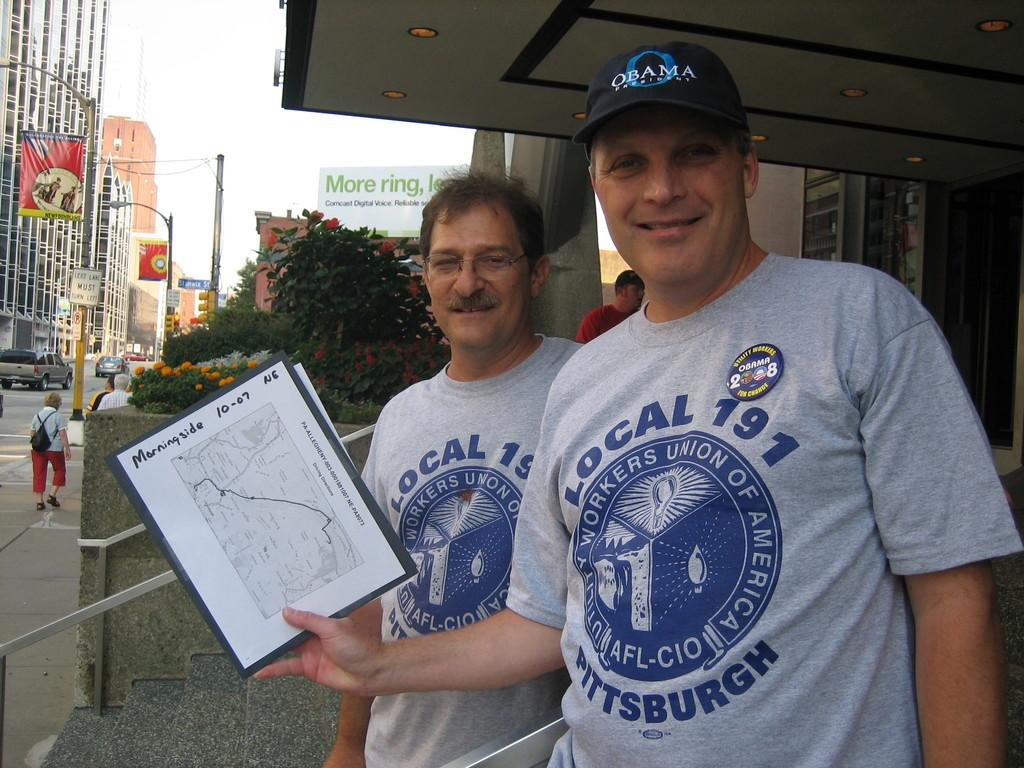<image>
Write a terse but informative summary of the picture. Two people standing and one man holding a paper that says 10-07. 